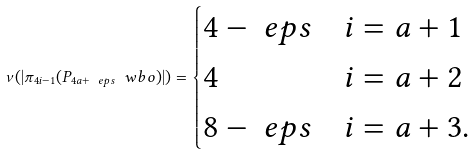<formula> <loc_0><loc_0><loc_500><loc_500>\nu ( | \pi _ { 4 i - 1 } ( P _ { 4 a + \ e p s } \ w b o ) | ) = \begin{cases} 4 - \ e p s & i = a + 1 \\ 4 & i = a + 2 \\ 8 - \ e p s & i = a + 3 . \end{cases}</formula> 